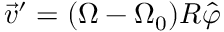<formula> <loc_0><loc_0><loc_500><loc_500>\vec { v } ^ { \prime } = ( { \Omega } - { \Omega } _ { 0 } ) R \hat { \varphi }</formula> 